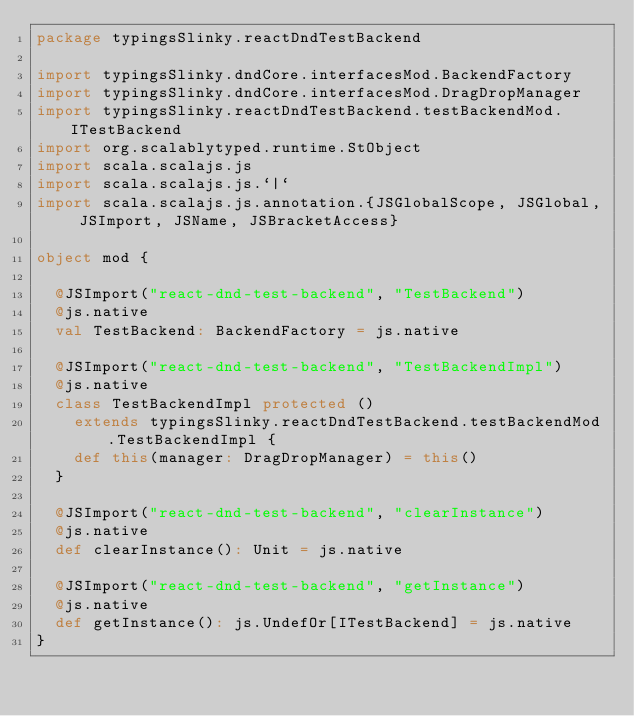Convert code to text. <code><loc_0><loc_0><loc_500><loc_500><_Scala_>package typingsSlinky.reactDndTestBackend

import typingsSlinky.dndCore.interfacesMod.BackendFactory
import typingsSlinky.dndCore.interfacesMod.DragDropManager
import typingsSlinky.reactDndTestBackend.testBackendMod.ITestBackend
import org.scalablytyped.runtime.StObject
import scala.scalajs.js
import scala.scalajs.js.`|`
import scala.scalajs.js.annotation.{JSGlobalScope, JSGlobal, JSImport, JSName, JSBracketAccess}

object mod {
  
  @JSImport("react-dnd-test-backend", "TestBackend")
  @js.native
  val TestBackend: BackendFactory = js.native
  
  @JSImport("react-dnd-test-backend", "TestBackendImpl")
  @js.native
  class TestBackendImpl protected ()
    extends typingsSlinky.reactDndTestBackend.testBackendMod.TestBackendImpl {
    def this(manager: DragDropManager) = this()
  }
  
  @JSImport("react-dnd-test-backend", "clearInstance")
  @js.native
  def clearInstance(): Unit = js.native
  
  @JSImport("react-dnd-test-backend", "getInstance")
  @js.native
  def getInstance(): js.UndefOr[ITestBackend] = js.native
}
</code> 